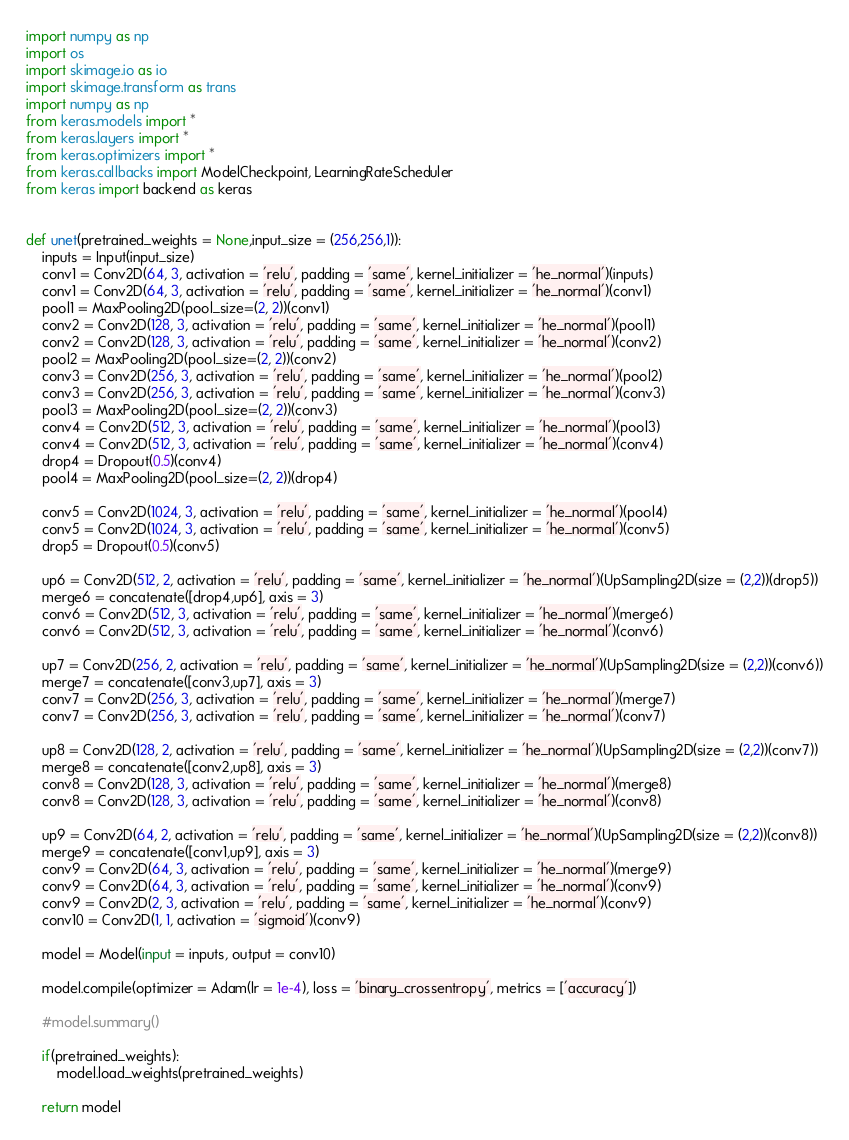Convert code to text. <code><loc_0><loc_0><loc_500><loc_500><_Python_>import numpy as np 
import os
import skimage.io as io
import skimage.transform as trans
import numpy as np
from keras.models import *
from keras.layers import *
from keras.optimizers import *
from keras.callbacks import ModelCheckpoint, LearningRateScheduler
from keras import backend as keras


def unet(pretrained_weights = None,input_size = (256,256,1)):
    inputs = Input(input_size)
    conv1 = Conv2D(64, 3, activation = 'relu', padding = 'same', kernel_initializer = 'he_normal')(inputs)
    conv1 = Conv2D(64, 3, activation = 'relu', padding = 'same', kernel_initializer = 'he_normal')(conv1)
    pool1 = MaxPooling2D(pool_size=(2, 2))(conv1)
    conv2 = Conv2D(128, 3, activation = 'relu', padding = 'same', kernel_initializer = 'he_normal')(pool1)
    conv2 = Conv2D(128, 3, activation = 'relu', padding = 'same', kernel_initializer = 'he_normal')(conv2)
    pool2 = MaxPooling2D(pool_size=(2, 2))(conv2)
    conv3 = Conv2D(256, 3, activation = 'relu', padding = 'same', kernel_initializer = 'he_normal')(pool2)
    conv3 = Conv2D(256, 3, activation = 'relu', padding = 'same', kernel_initializer = 'he_normal')(conv3)
    pool3 = MaxPooling2D(pool_size=(2, 2))(conv3)
    conv4 = Conv2D(512, 3, activation = 'relu', padding = 'same', kernel_initializer = 'he_normal')(pool3)
    conv4 = Conv2D(512, 3, activation = 'relu', padding = 'same', kernel_initializer = 'he_normal')(conv4)
    drop4 = Dropout(0.5)(conv4)
    pool4 = MaxPooling2D(pool_size=(2, 2))(drop4)

    conv5 = Conv2D(1024, 3, activation = 'relu', padding = 'same', kernel_initializer = 'he_normal')(pool4)
    conv5 = Conv2D(1024, 3, activation = 'relu', padding = 'same', kernel_initializer = 'he_normal')(conv5)
    drop5 = Dropout(0.5)(conv5)

    up6 = Conv2D(512, 2, activation = 'relu', padding = 'same', kernel_initializer = 'he_normal')(UpSampling2D(size = (2,2))(drop5))
    merge6 = concatenate([drop4,up6], axis = 3)
    conv6 = Conv2D(512, 3, activation = 'relu', padding = 'same', kernel_initializer = 'he_normal')(merge6)
    conv6 = Conv2D(512, 3, activation = 'relu', padding = 'same', kernel_initializer = 'he_normal')(conv6)

    up7 = Conv2D(256, 2, activation = 'relu', padding = 'same', kernel_initializer = 'he_normal')(UpSampling2D(size = (2,2))(conv6))
    merge7 = concatenate([conv3,up7], axis = 3)
    conv7 = Conv2D(256, 3, activation = 'relu', padding = 'same', kernel_initializer = 'he_normal')(merge7)
    conv7 = Conv2D(256, 3, activation = 'relu', padding = 'same', kernel_initializer = 'he_normal')(conv7)

    up8 = Conv2D(128, 2, activation = 'relu', padding = 'same', kernel_initializer = 'he_normal')(UpSampling2D(size = (2,2))(conv7))
    merge8 = concatenate([conv2,up8], axis = 3)
    conv8 = Conv2D(128, 3, activation = 'relu', padding = 'same', kernel_initializer = 'he_normal')(merge8)
    conv8 = Conv2D(128, 3, activation = 'relu', padding = 'same', kernel_initializer = 'he_normal')(conv8)

    up9 = Conv2D(64, 2, activation = 'relu', padding = 'same', kernel_initializer = 'he_normal')(UpSampling2D(size = (2,2))(conv8))
    merge9 = concatenate([conv1,up9], axis = 3)
    conv9 = Conv2D(64, 3, activation = 'relu', padding = 'same', kernel_initializer = 'he_normal')(merge9)
    conv9 = Conv2D(64, 3, activation = 'relu', padding = 'same', kernel_initializer = 'he_normal')(conv9)
    conv9 = Conv2D(2, 3, activation = 'relu', padding = 'same', kernel_initializer = 'he_normal')(conv9)
    conv10 = Conv2D(1, 1, activation = 'sigmoid')(conv9)

    model = Model(input = inputs, output = conv10)

    model.compile(optimizer = Adam(lr = 1e-4), loss = 'binary_crossentropy', metrics = ['accuracy'])
    
    #model.summary()

    if(pretrained_weights):
    	model.load_weights(pretrained_weights)

    return model</code> 